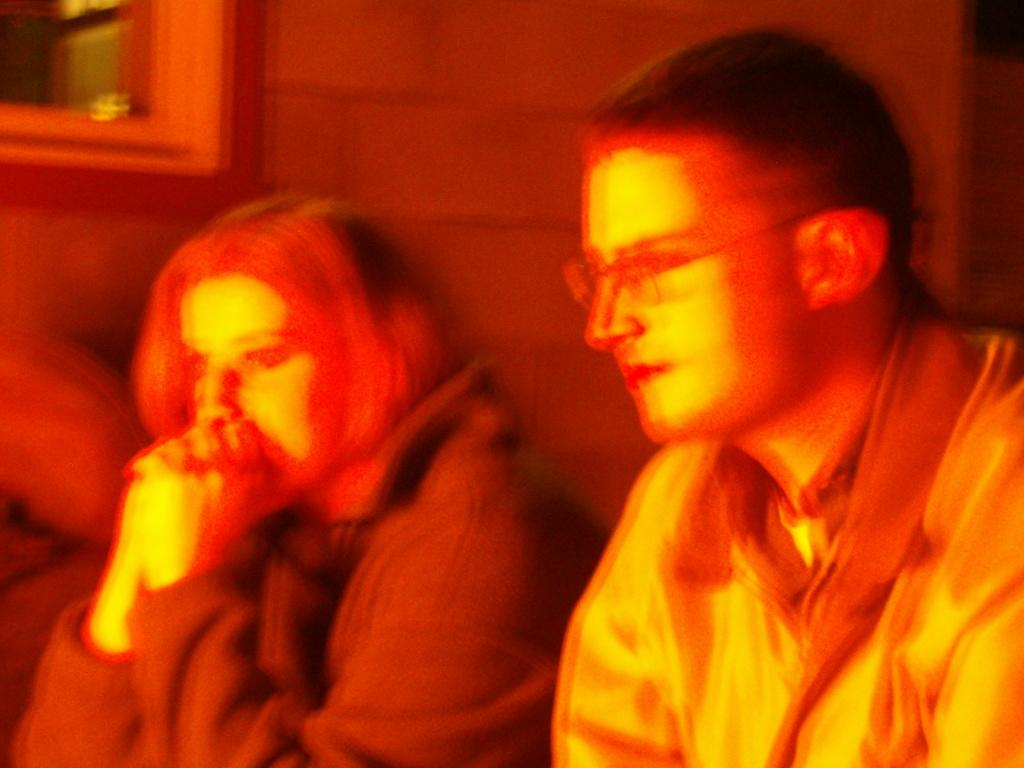How many people are in the image? There are two people in the image, a man and a woman. What are the man and woman doing in the image? The man and woman are sitting. Can you describe the positions of the man and woman in the image? Unfortunately, the provided facts do not give enough information to describe their positions. What type of fuel is being used by the rainstorm in the image? There is no rainstorm present in the image, and therefore no fuel can be associated with it. 